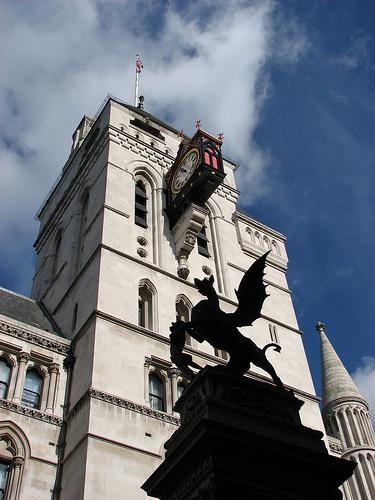Question: what color is the building?
Choices:
A. Teal.
B. Purple.
C. White.
D. Neon.
Answer with the letter. Answer: C Question: where is the clock?
Choices:
A. On the tower.
B. On the side of the building.
C. In the room.
D. On the desk.
Answer with the letter. Answer: B 